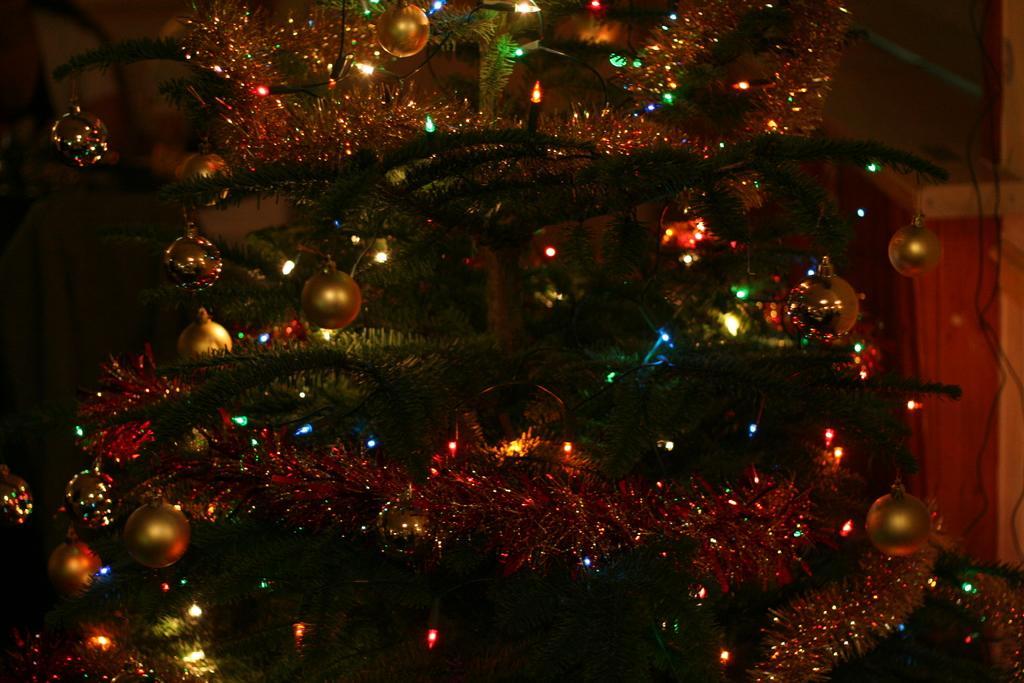Please provide a concise description of this image. In this image we can see a tree which is decorated with some balls and lights. 